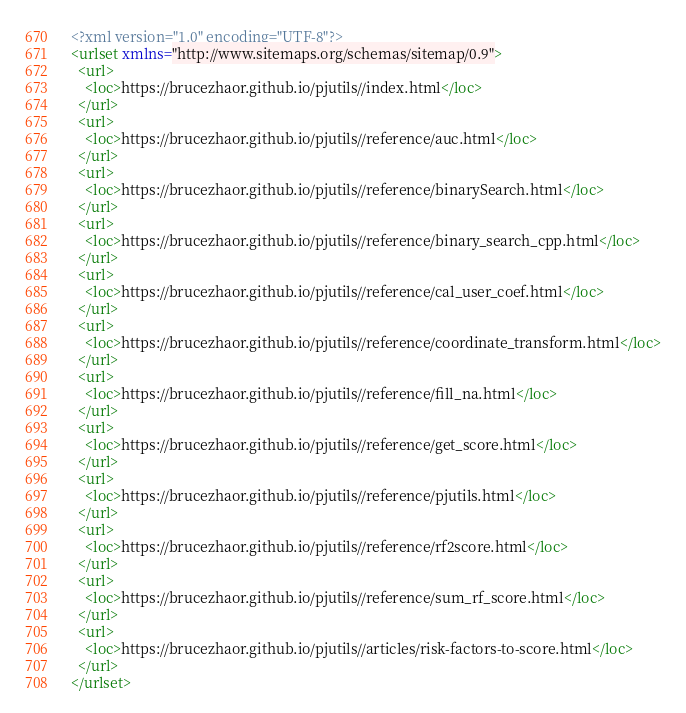<code> <loc_0><loc_0><loc_500><loc_500><_XML_><?xml version="1.0" encoding="UTF-8"?>
<urlset xmlns="http://www.sitemaps.org/schemas/sitemap/0.9">
  <url>
    <loc>https://brucezhaor.github.io/pjutils//index.html</loc>
  </url>
  <url>
    <loc>https://brucezhaor.github.io/pjutils//reference/auc.html</loc>
  </url>
  <url>
    <loc>https://brucezhaor.github.io/pjutils//reference/binarySearch.html</loc>
  </url>
  <url>
    <loc>https://brucezhaor.github.io/pjutils//reference/binary_search_cpp.html</loc>
  </url>
  <url>
    <loc>https://brucezhaor.github.io/pjutils//reference/cal_user_coef.html</loc>
  </url>
  <url>
    <loc>https://brucezhaor.github.io/pjutils//reference/coordinate_transform.html</loc>
  </url>
  <url>
    <loc>https://brucezhaor.github.io/pjutils//reference/fill_na.html</loc>
  </url>
  <url>
    <loc>https://brucezhaor.github.io/pjutils//reference/get_score.html</loc>
  </url>
  <url>
    <loc>https://brucezhaor.github.io/pjutils//reference/pjutils.html</loc>
  </url>
  <url>
    <loc>https://brucezhaor.github.io/pjutils//reference/rf2score.html</loc>
  </url>
  <url>
    <loc>https://brucezhaor.github.io/pjutils//reference/sum_rf_score.html</loc>
  </url>
  <url>
    <loc>https://brucezhaor.github.io/pjutils//articles/risk-factors-to-score.html</loc>
  </url>
</urlset>
</code> 